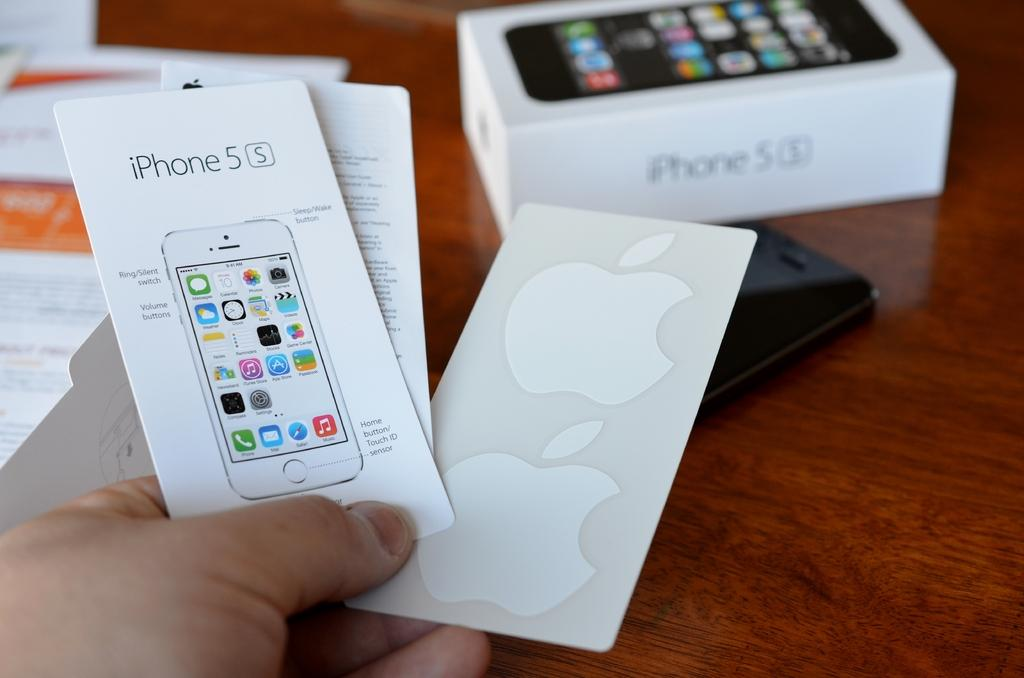<image>
Share a concise interpretation of the image provided. A hand is holding an iphone 5s booklet and Apple stickers with a box for the iphone 5s in the background. 